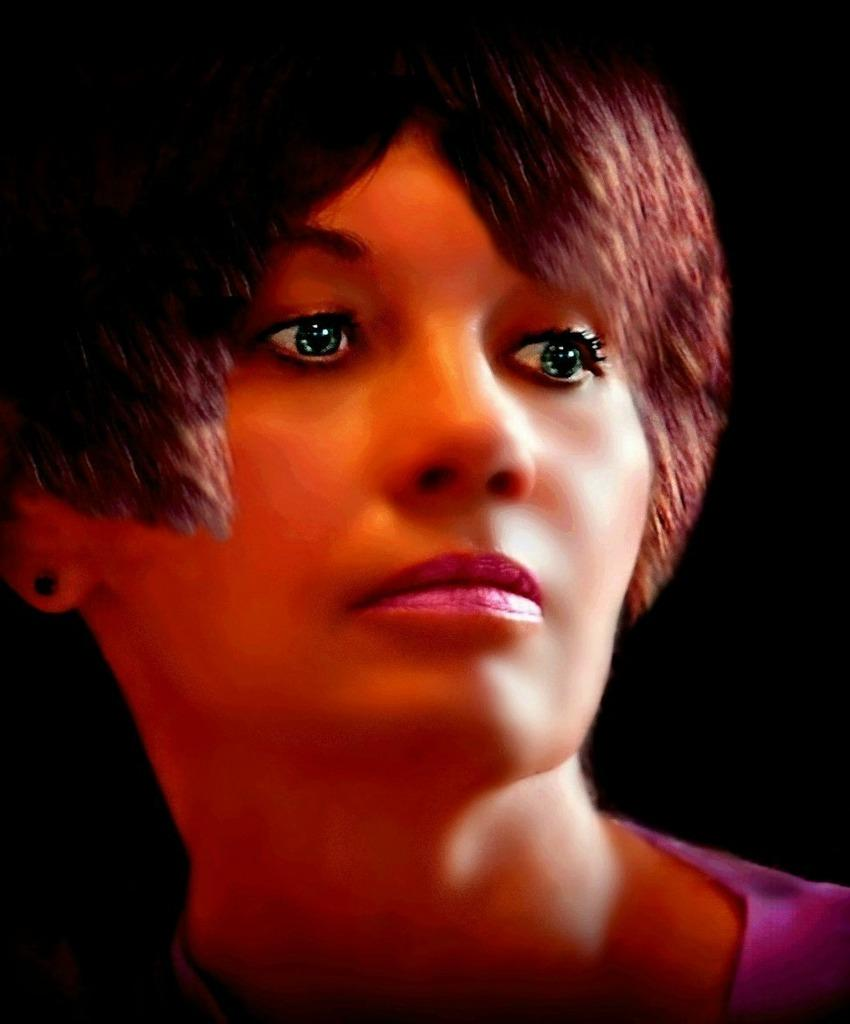What type of image is being described? The image is animated. What can be observed about the background of the image? The background of the image is dark. Who or what is the main subject in the image? There is a woman in the middle of the image. What type of bun is the woman holding in the image? There is no bun present in the image. Can you see a ball being played with by the woman in the image? There is no ball present in the image. Is there a deer visible in the image? There is no deer present in the image. 